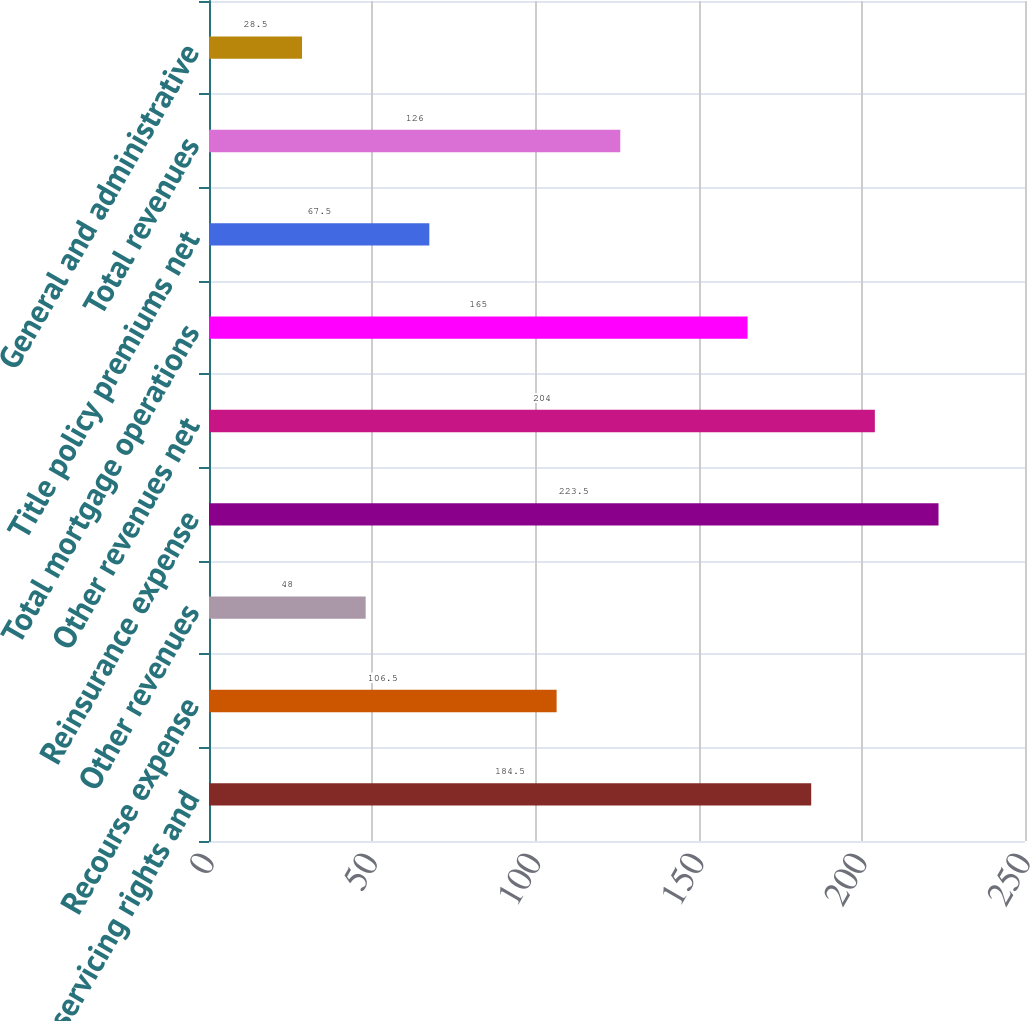Convert chart. <chart><loc_0><loc_0><loc_500><loc_500><bar_chart><fcel>Sale of servicing rights and<fcel>Recourse expense<fcel>Other revenues<fcel>Reinsurance expense<fcel>Other revenues net<fcel>Total mortgage operations<fcel>Title policy premiums net<fcel>Total revenues<fcel>General and administrative<nl><fcel>184.5<fcel>106.5<fcel>48<fcel>223.5<fcel>204<fcel>165<fcel>67.5<fcel>126<fcel>28.5<nl></chart> 